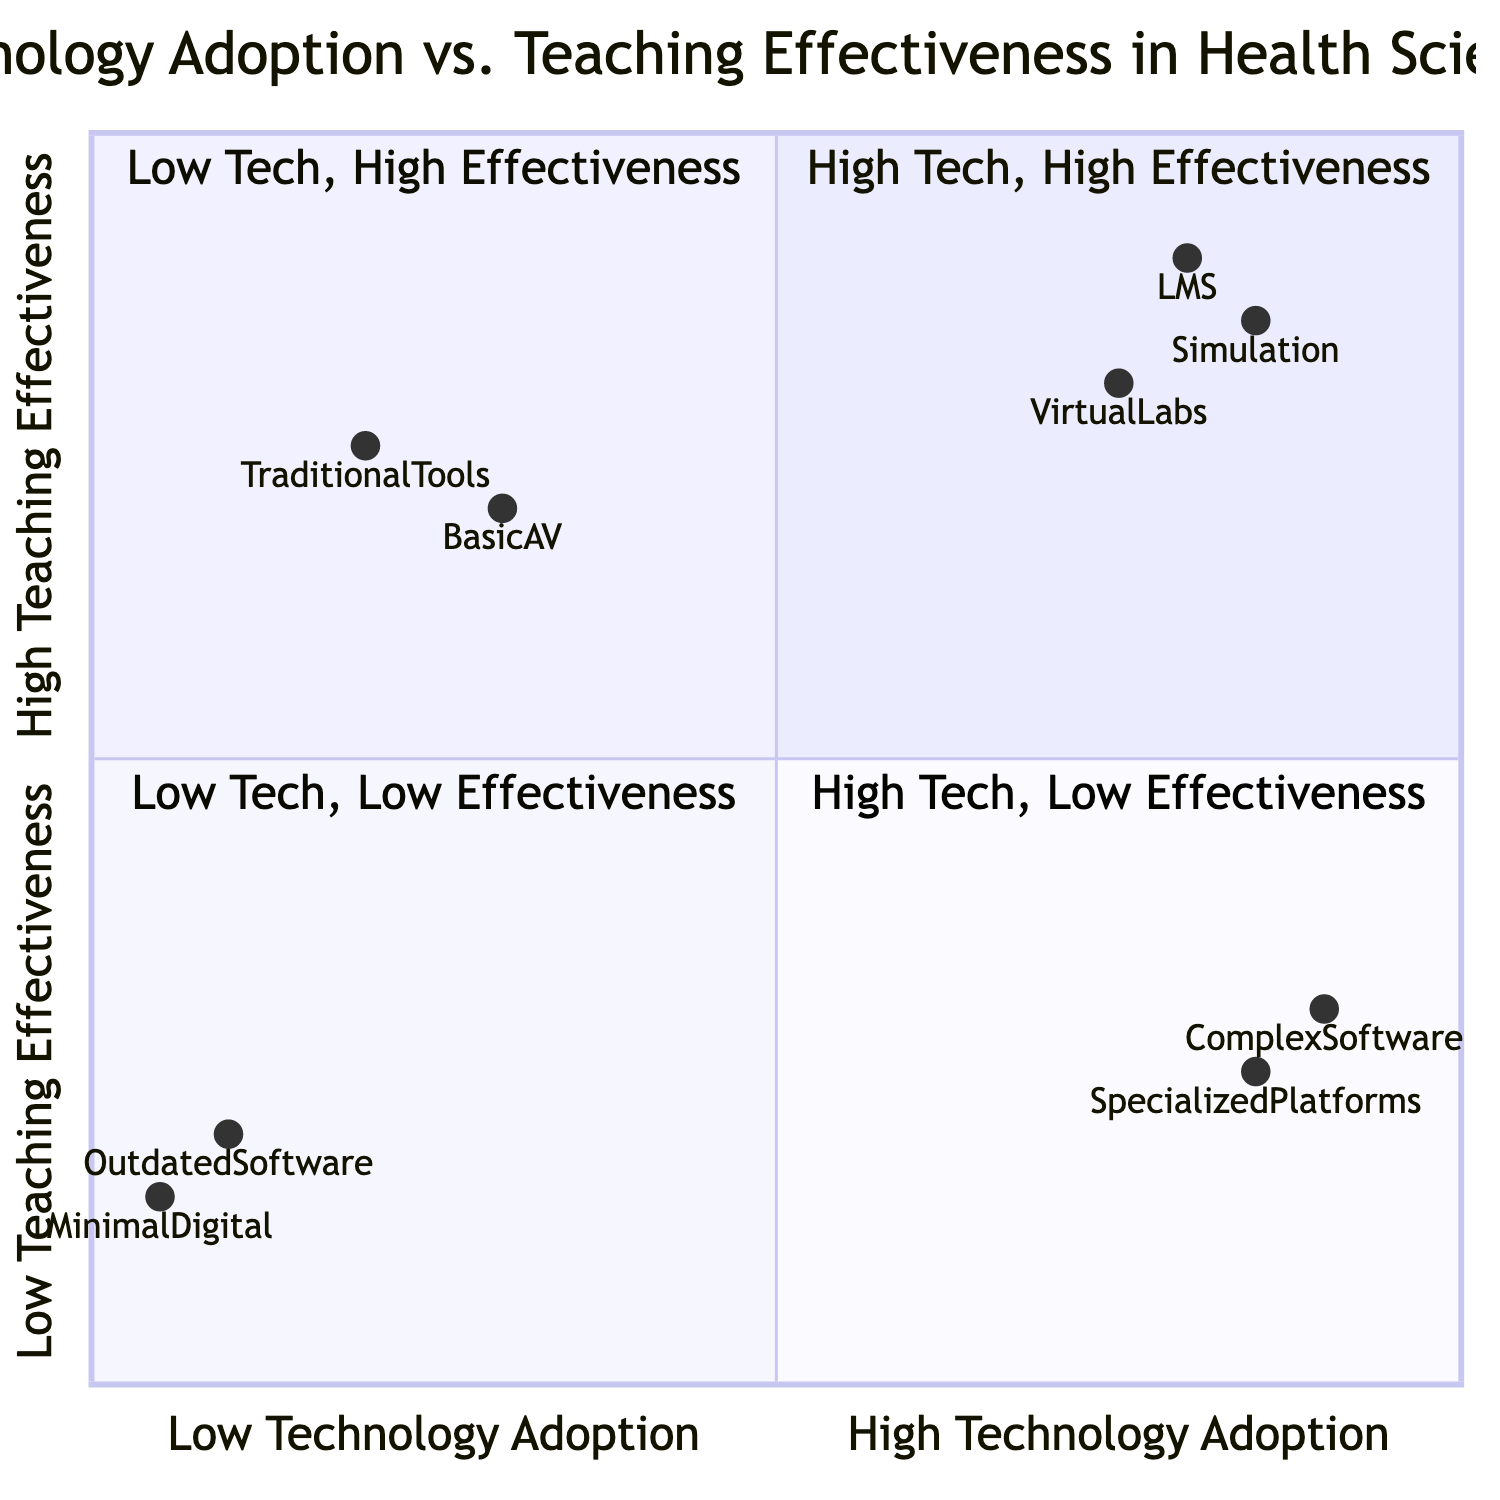What technologies are in the "High Technology Adoption, High Teaching Effectiveness" quadrant? The "High Technology Adoption, High Teaching Effectiveness" quadrant includes "Learning Management Systems (e.g., Blackboard, Canvas)", "Simulation Software (e.g., SimMan, iStan)", and "Virtual Labs (e.g., Labster)".
Answer: Learning Management Systems, Simulation Software, Virtual Labs Which quadrant has "Outdated Software" as a technology? "Outdated Software" is located in the "Low Technology Adoption, Low Teaching Effectiveness" quadrant.
Answer: Low Technology Adoption, Low Teaching Effectiveness What is the impact of using traditional tools in the "Low Technology Adoption, High Teaching Effectiveness" quadrant? The impact of using traditional tools includes high teaching effectiveness through familiarity, ease of use, and direct student-faculty interactions.
Answer: High teaching effectiveness due to familiarity and ease of use How many technologies are listed in the "High Technology Adoption, Low Teaching Effectiveness" quadrant? There are two technologies listed in the "High Technology Adoption, Low Teaching Effectiveness" quadrant: "Complex Custom Software" and "Highly Specialized Simulation Platforms without proper training".
Answer: Two technologies What is the impact for technologies in the "Low Technology Adoption, Low Teaching Effectiveness" quadrant? The impact for technologies in the "Low Technology Adoption, Low Teaching Effectiveness" quadrant includes poor teaching outcomes due to lack of engagement, outdated materials, and limited student interactivity.
Answer: Poor teaching outcomes due to lack of engagement and outdated materials Which technology has the highest adoption rate among those listed? The technology with the highest adoption rate is "Complex Custom Software", which is situated at 0.9 on the x-axis.
Answer: Complex Custom Software What does the "High Technology Adoption, low Teaching Effectiveness" quadrant indicate about training needs? It indicates a need for adequate training to bridge the gap between advanced technology use and actual teaching effectiveness.
Answer: A need for adequate training to improve effectiveness 